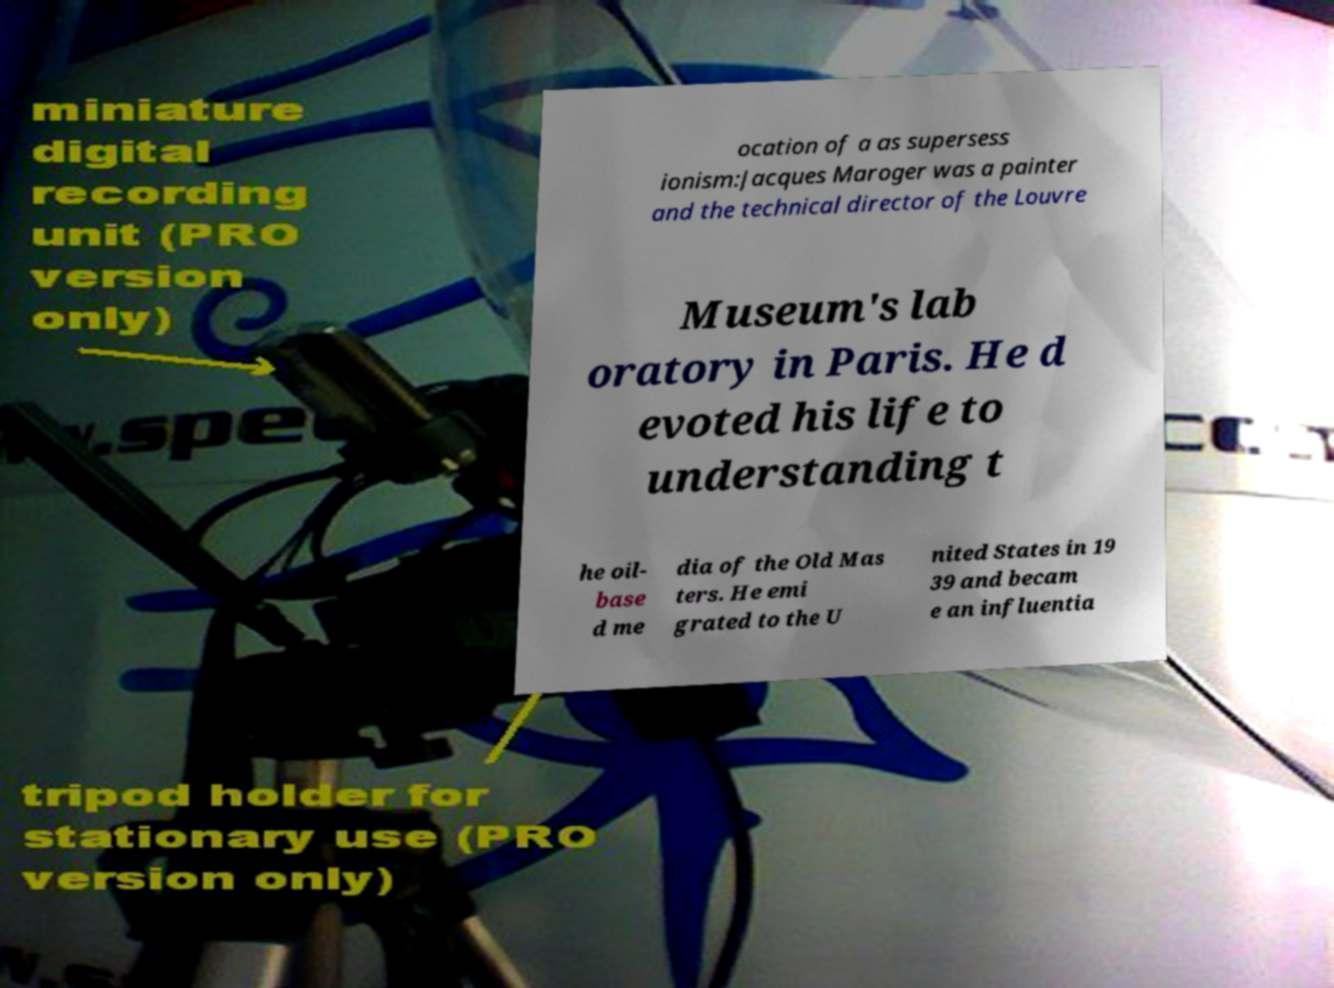Can you accurately transcribe the text from the provided image for me? ocation of a as supersess ionism:Jacques Maroger was a painter and the technical director of the Louvre Museum's lab oratory in Paris. He d evoted his life to understanding t he oil- base d me dia of the Old Mas ters. He emi grated to the U nited States in 19 39 and becam e an influentia 